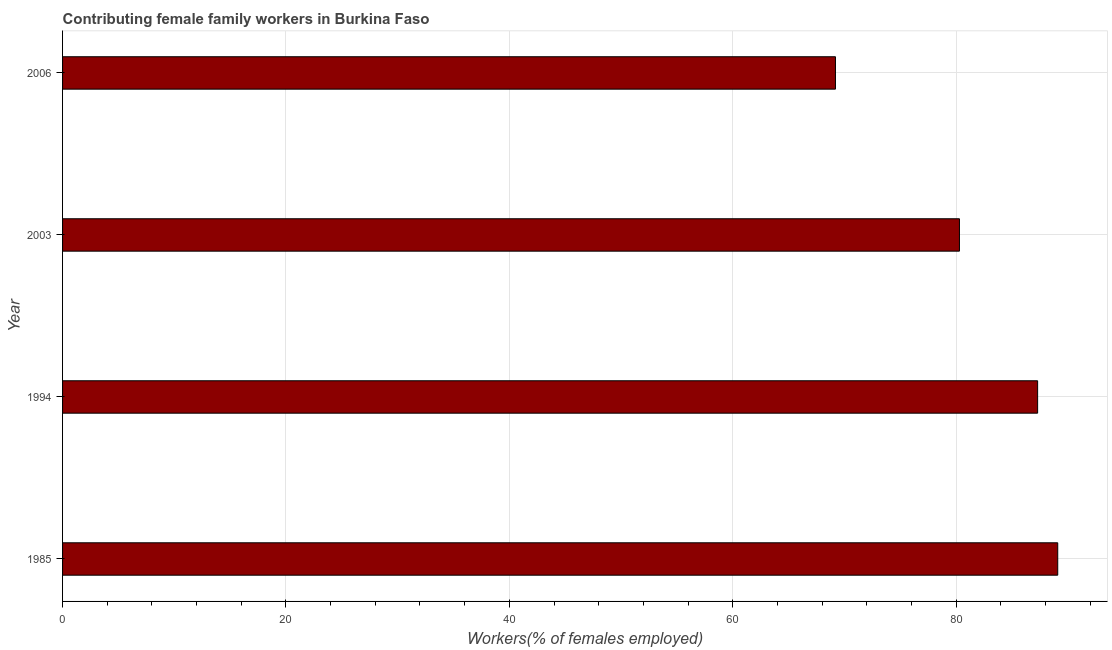What is the title of the graph?
Provide a short and direct response. Contributing female family workers in Burkina Faso. What is the label or title of the X-axis?
Your answer should be compact. Workers(% of females employed). What is the contributing female family workers in 2003?
Make the answer very short. 80.3. Across all years, what is the maximum contributing female family workers?
Ensure brevity in your answer.  89.1. Across all years, what is the minimum contributing female family workers?
Your response must be concise. 69.2. What is the sum of the contributing female family workers?
Provide a succinct answer. 325.9. What is the average contributing female family workers per year?
Your answer should be very brief. 81.47. What is the median contributing female family workers?
Make the answer very short. 83.8. In how many years, is the contributing female family workers greater than 84 %?
Make the answer very short. 2. Do a majority of the years between 1985 and 1994 (inclusive) have contributing female family workers greater than 4 %?
Offer a terse response. Yes. What is the ratio of the contributing female family workers in 1985 to that in 2006?
Your answer should be compact. 1.29. Is the contributing female family workers in 2003 less than that in 2006?
Offer a very short reply. No. Is the difference between the contributing female family workers in 1994 and 2006 greater than the difference between any two years?
Provide a succinct answer. No. What is the difference between the highest and the second highest contributing female family workers?
Your answer should be very brief. 1.8. What is the difference between the highest and the lowest contributing female family workers?
Offer a terse response. 19.9. How many bars are there?
Make the answer very short. 4. Are all the bars in the graph horizontal?
Ensure brevity in your answer.  Yes. How many years are there in the graph?
Ensure brevity in your answer.  4. Are the values on the major ticks of X-axis written in scientific E-notation?
Give a very brief answer. No. What is the Workers(% of females employed) in 1985?
Provide a short and direct response. 89.1. What is the Workers(% of females employed) in 1994?
Ensure brevity in your answer.  87.3. What is the Workers(% of females employed) in 2003?
Your answer should be very brief. 80.3. What is the Workers(% of females employed) in 2006?
Provide a short and direct response. 69.2. What is the difference between the Workers(% of females employed) in 1985 and 2003?
Offer a terse response. 8.8. What is the difference between the Workers(% of females employed) in 1985 and 2006?
Provide a succinct answer. 19.9. What is the difference between the Workers(% of females employed) in 1994 and 2003?
Give a very brief answer. 7. What is the difference between the Workers(% of females employed) in 1994 and 2006?
Provide a short and direct response. 18.1. What is the difference between the Workers(% of females employed) in 2003 and 2006?
Offer a very short reply. 11.1. What is the ratio of the Workers(% of females employed) in 1985 to that in 1994?
Provide a succinct answer. 1.02. What is the ratio of the Workers(% of females employed) in 1985 to that in 2003?
Your answer should be very brief. 1.11. What is the ratio of the Workers(% of females employed) in 1985 to that in 2006?
Your response must be concise. 1.29. What is the ratio of the Workers(% of females employed) in 1994 to that in 2003?
Keep it short and to the point. 1.09. What is the ratio of the Workers(% of females employed) in 1994 to that in 2006?
Your answer should be compact. 1.26. What is the ratio of the Workers(% of females employed) in 2003 to that in 2006?
Your response must be concise. 1.16. 